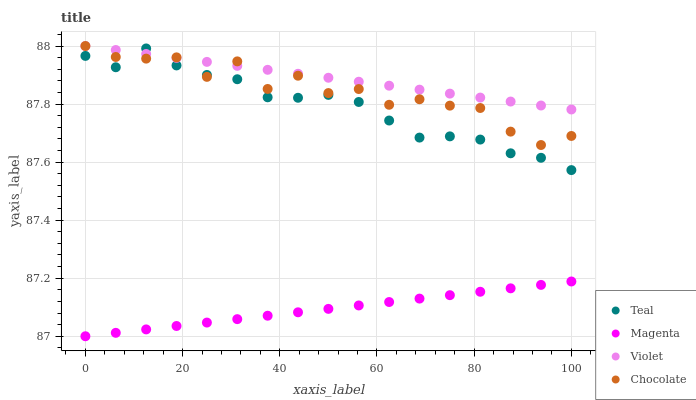Does Magenta have the minimum area under the curve?
Answer yes or no. Yes. Does Violet have the maximum area under the curve?
Answer yes or no. Yes. Does Chocolate have the minimum area under the curve?
Answer yes or no. No. Does Chocolate have the maximum area under the curve?
Answer yes or no. No. Is Magenta the smoothest?
Answer yes or no. Yes. Is Chocolate the roughest?
Answer yes or no. Yes. Is Teal the smoothest?
Answer yes or no. No. Is Teal the roughest?
Answer yes or no. No. Does Magenta have the lowest value?
Answer yes or no. Yes. Does Chocolate have the lowest value?
Answer yes or no. No. Does Violet have the highest value?
Answer yes or no. Yes. Does Teal have the highest value?
Answer yes or no. No. Is Magenta less than Chocolate?
Answer yes or no. Yes. Is Teal greater than Magenta?
Answer yes or no. Yes. Does Teal intersect Chocolate?
Answer yes or no. Yes. Is Teal less than Chocolate?
Answer yes or no. No. Is Teal greater than Chocolate?
Answer yes or no. No. Does Magenta intersect Chocolate?
Answer yes or no. No. 